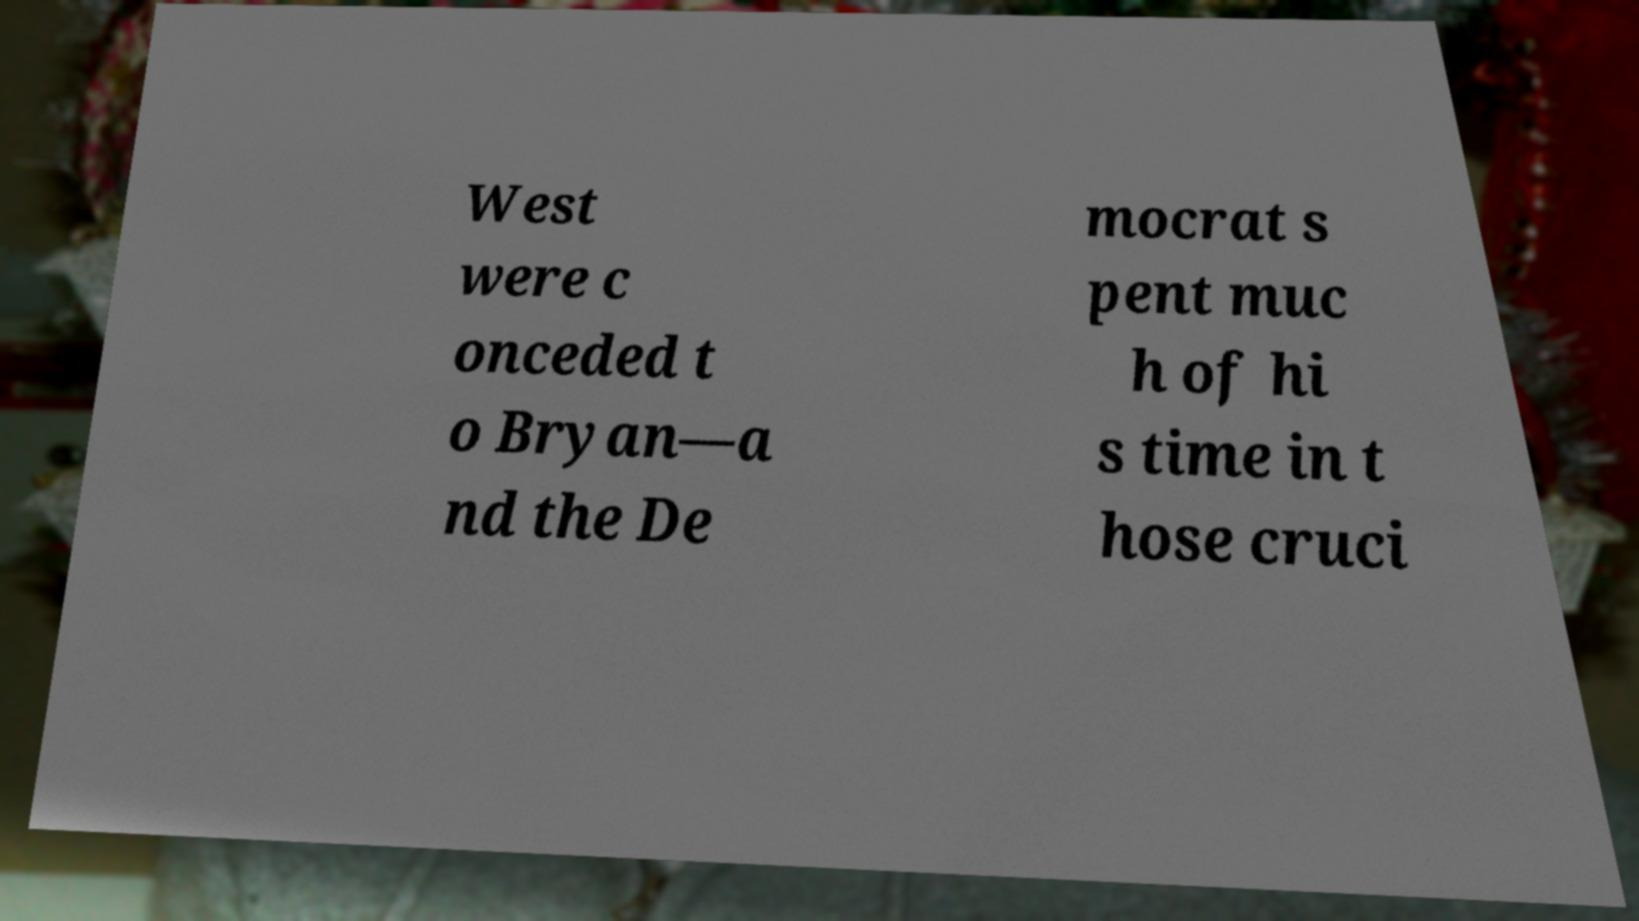Please read and relay the text visible in this image. What does it say? West were c onceded t o Bryan—a nd the De mocrat s pent muc h of hi s time in t hose cruci 